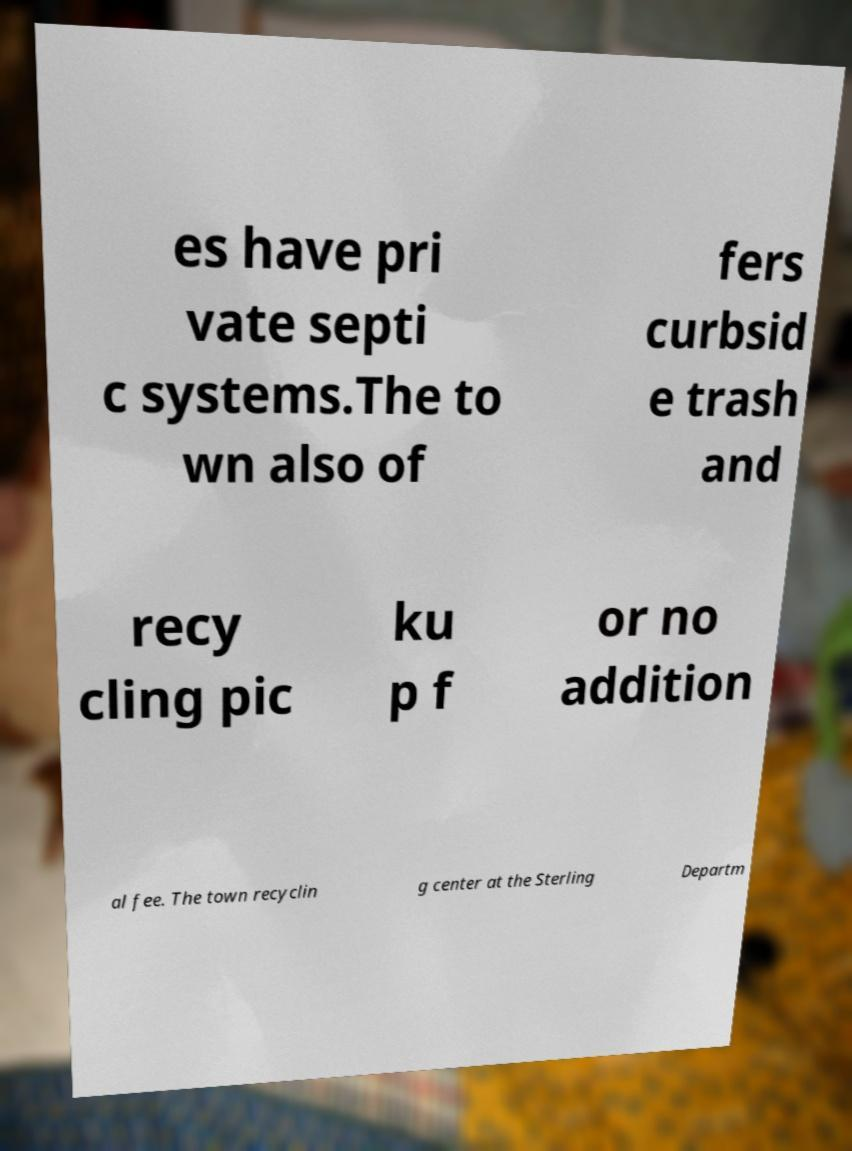I need the written content from this picture converted into text. Can you do that? es have pri vate septi c systems.The to wn also of fers curbsid e trash and recy cling pic ku p f or no addition al fee. The town recyclin g center at the Sterling Departm 